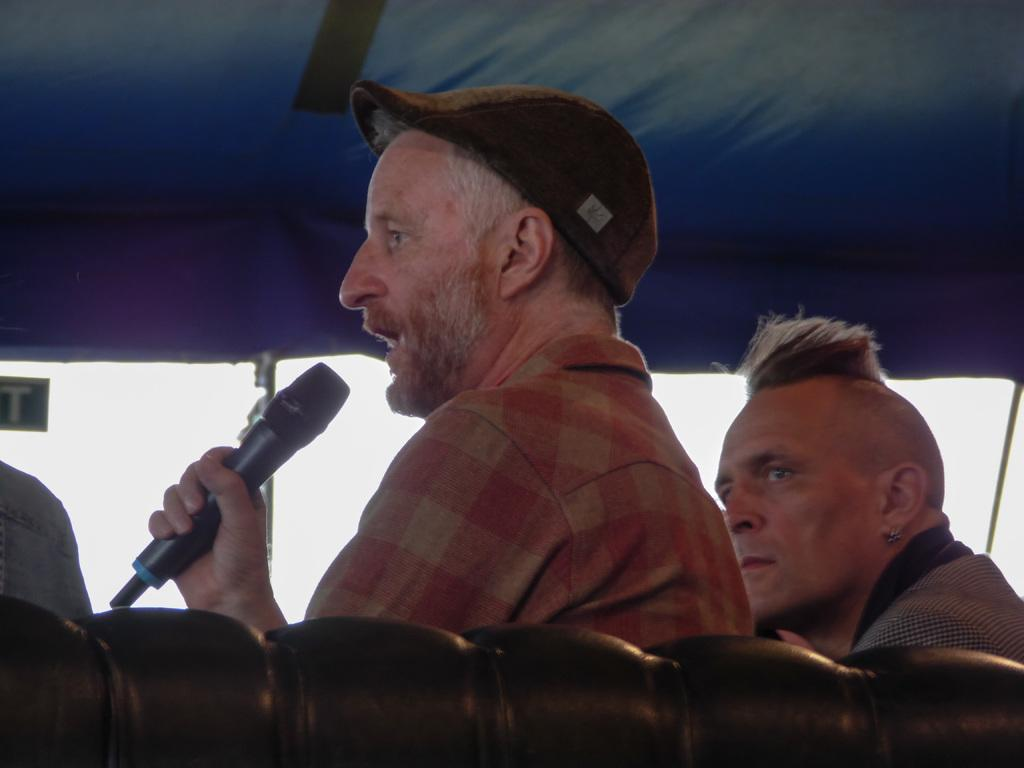How many people are in the image? There are two persons in the image. What is one person doing in the image? One person is holding a mic in his hand. Can you describe the appearance of the person with the mic? The person with the mic is wearing a hat. What is the other person doing in the image? The other person is watching the person with the mic. What can be seen in the background of the image? There is a sky and a tent visible in the background of the image. How many trains can be seen passing through the border in the image? There are no trains or borders present in the image. What type of string is being used to hold up the tent in the image? There is no string visible in the image, and the tent's support structure is not mentioned in the provided facts. 